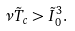Convert formula to latex. <formula><loc_0><loc_0><loc_500><loc_500>\nu \tilde { T } _ { c } > \tilde { I } _ { 0 } ^ { 3 } .</formula> 